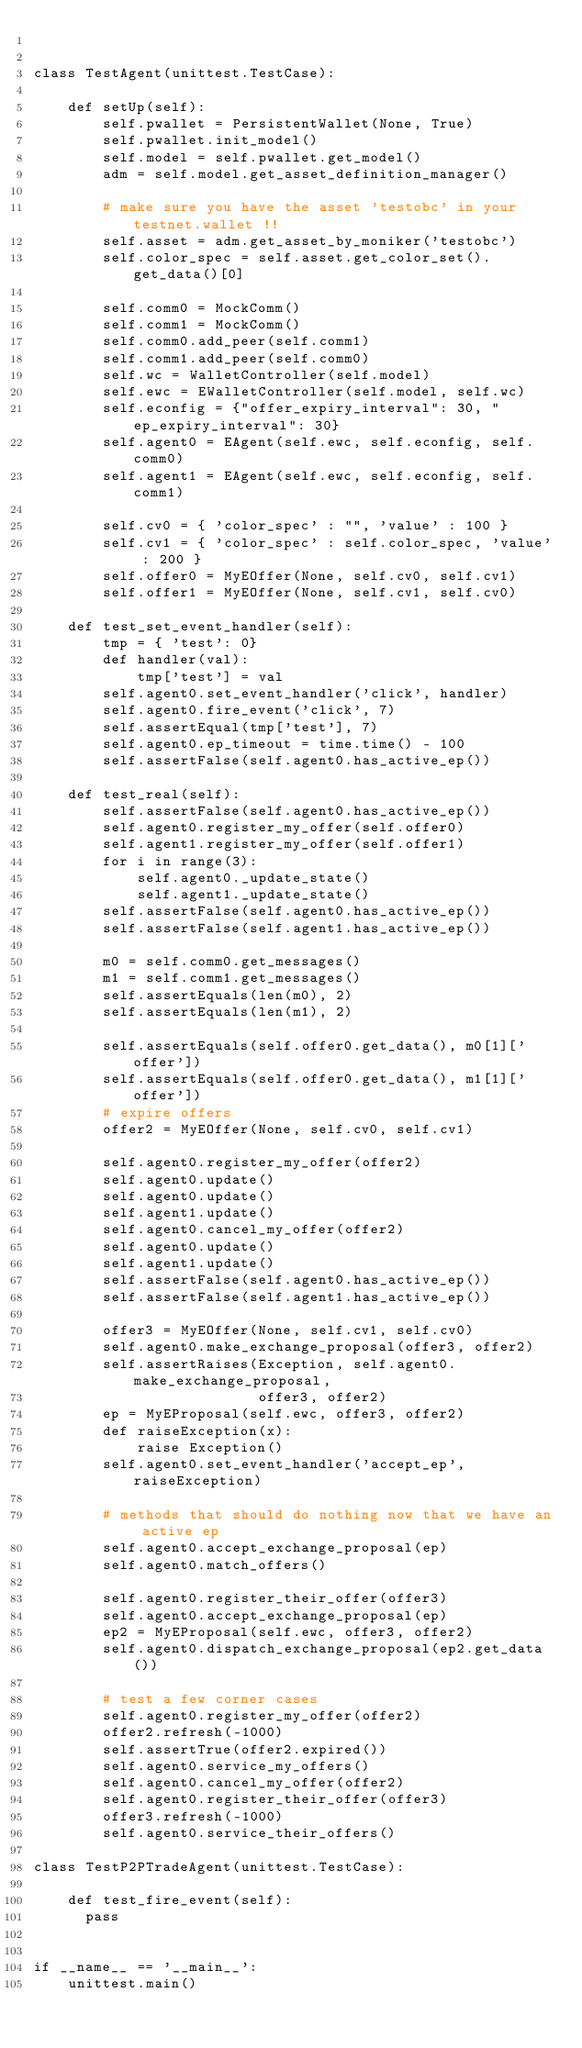Convert code to text. <code><loc_0><loc_0><loc_500><loc_500><_Python_>

class TestAgent(unittest.TestCase):

    def setUp(self):
        self.pwallet = PersistentWallet(None, True)
        self.pwallet.init_model()
        self.model = self.pwallet.get_model()
        adm = self.model.get_asset_definition_manager()

        # make sure you have the asset 'testobc' in your testnet.wallet !!
        self.asset = adm.get_asset_by_moniker('testobc')
        self.color_spec = self.asset.get_color_set().get_data()[0]

        self.comm0 = MockComm()
        self.comm1 = MockComm()
        self.comm0.add_peer(self.comm1)
        self.comm1.add_peer(self.comm0)
        self.wc = WalletController(self.model)
        self.ewc = EWalletController(self.model, self.wc)
        self.econfig = {"offer_expiry_interval": 30, "ep_expiry_interval": 30}
        self.agent0 = EAgent(self.ewc, self.econfig, self.comm0)
        self.agent1 = EAgent(self.ewc, self.econfig, self.comm1)

        self.cv0 = { 'color_spec' : "", 'value' : 100 }
        self.cv1 = { 'color_spec' : self.color_spec, 'value' : 200 }
        self.offer0 = MyEOffer(None, self.cv0, self.cv1)
        self.offer1 = MyEOffer(None, self.cv1, self.cv0)

    def test_set_event_handler(self):
        tmp = { 'test': 0}
        def handler(val):
            tmp['test'] = val
        self.agent0.set_event_handler('click', handler)
        self.agent0.fire_event('click', 7)
        self.assertEqual(tmp['test'], 7)
        self.agent0.ep_timeout = time.time() - 100
        self.assertFalse(self.agent0.has_active_ep())

    def test_real(self):
        self.assertFalse(self.agent0.has_active_ep())
        self.agent0.register_my_offer(self.offer0)
        self.agent1.register_my_offer(self.offer1)
        for i in range(3):
            self.agent0._update_state()
            self.agent1._update_state()
        self.assertFalse(self.agent0.has_active_ep())
        self.assertFalse(self.agent1.has_active_ep())

        m0 = self.comm0.get_messages()
        m1 = self.comm1.get_messages()
        self.assertEquals(len(m0), 2)
        self.assertEquals(len(m1), 2)

        self.assertEquals(self.offer0.get_data(), m0[1]['offer'])
        self.assertEquals(self.offer0.get_data(), m1[1]['offer'])
        # expire offers
        offer2 = MyEOffer(None, self.cv0, self.cv1)

        self.agent0.register_my_offer(offer2)
        self.agent0.update()
        self.agent0.update()
        self.agent1.update()
        self.agent0.cancel_my_offer(offer2)
        self.agent0.update()
        self.agent1.update()
        self.assertFalse(self.agent0.has_active_ep())
        self.assertFalse(self.agent1.has_active_ep())

        offer3 = MyEOffer(None, self.cv1, self.cv0)
        self.agent0.make_exchange_proposal(offer3, offer2)
        self.assertRaises(Exception, self.agent0.make_exchange_proposal,
                          offer3, offer2)
        ep = MyEProposal(self.ewc, offer3, offer2)
        def raiseException(x):
            raise Exception()
        self.agent0.set_event_handler('accept_ep', raiseException)

        # methods that should do nothing now that we have an active ep
        self.agent0.accept_exchange_proposal(ep)
        self.agent0.match_offers()

        self.agent0.register_their_offer(offer3)
        self.agent0.accept_exchange_proposal(ep)
        ep2 = MyEProposal(self.ewc, offer3, offer2)
        self.agent0.dispatch_exchange_proposal(ep2.get_data())

        # test a few corner cases
        self.agent0.register_my_offer(offer2)
        offer2.refresh(-1000)
        self.assertTrue(offer2.expired())
        self.agent0.service_my_offers()
        self.agent0.cancel_my_offer(offer2)
        self.agent0.register_their_offer(offer3)
        offer3.refresh(-1000)
        self.agent0.service_their_offers()

class TestP2PTradeAgent(unittest.TestCase):

    def test_fire_event(self):
      pass


if __name__ == '__main__':
    unittest.main()
</code> 